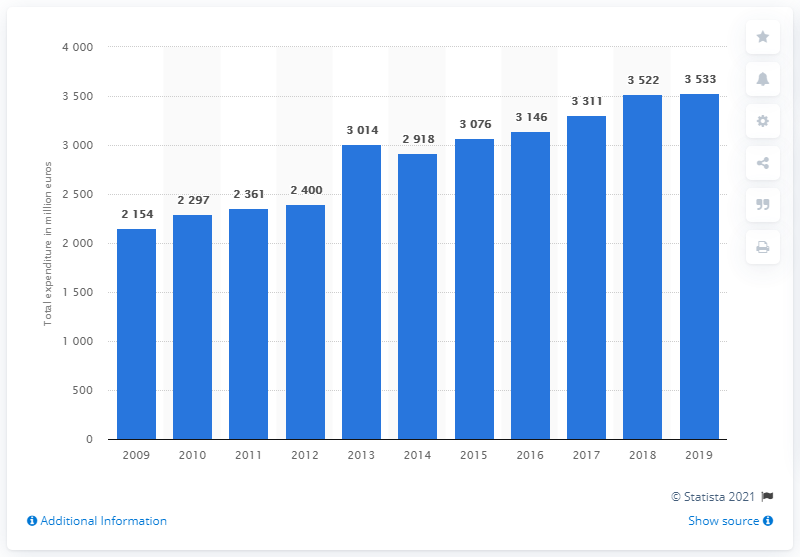Draw attention to some important aspects in this diagram. Finland's government spending increased by 3533% from 2009 to 2019. The total expenditure on recreation, culture, and religion in Finland in 2019 was 3533. 